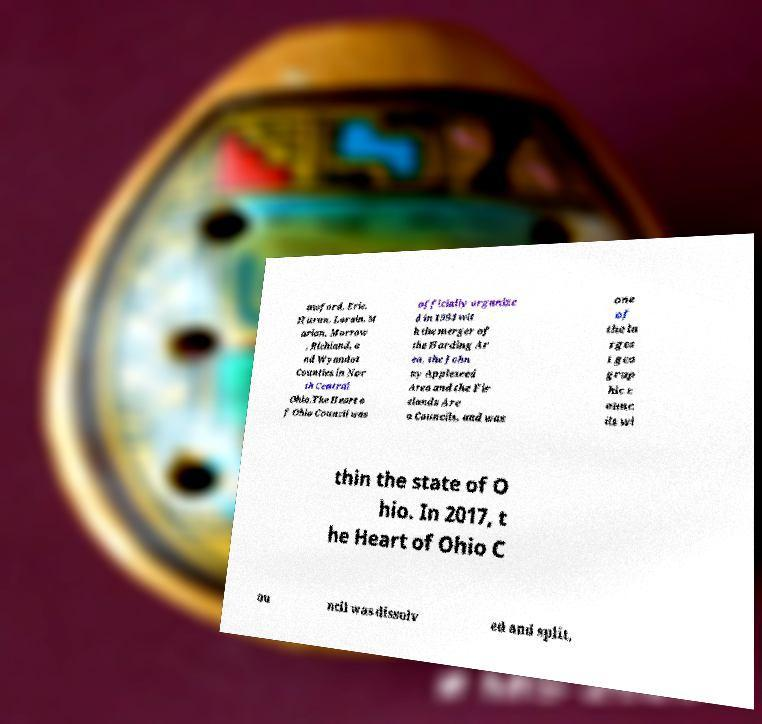Can you accurately transcribe the text from the provided image for me? awford, Erie, Huron, Lorain, M arion, Morrow , Richland, a nd Wyandot Counties in Nor th Central Ohio.The Heart o f Ohio Council was officially organize d in 1994 wit h the merger of the Harding Ar ea, the John ny Appleseed Area and the Fir elands Are a Councils, and was one of the la rges t geo grap hic c ounc ils wi thin the state of O hio. In 2017, t he Heart of Ohio C ou ncil was dissolv ed and split, 